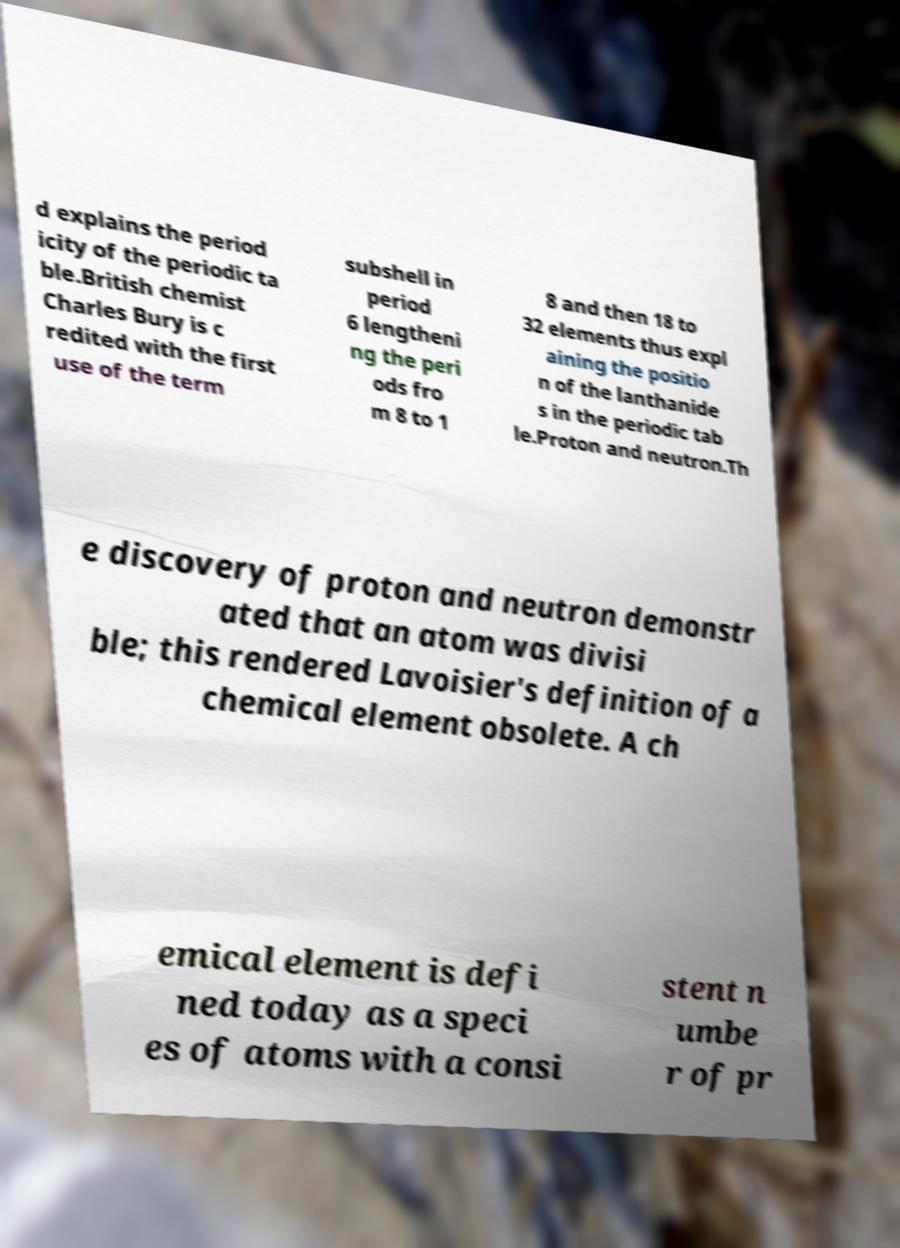Please read and relay the text visible in this image. What does it say? d explains the period icity of the periodic ta ble.British chemist Charles Bury is c redited with the first use of the term subshell in period 6 lengtheni ng the peri ods fro m 8 to 1 8 and then 18 to 32 elements thus expl aining the positio n of the lanthanide s in the periodic tab le.Proton and neutron.Th e discovery of proton and neutron demonstr ated that an atom was divisi ble; this rendered Lavoisier's definition of a chemical element obsolete. A ch emical element is defi ned today as a speci es of atoms with a consi stent n umbe r of pr 